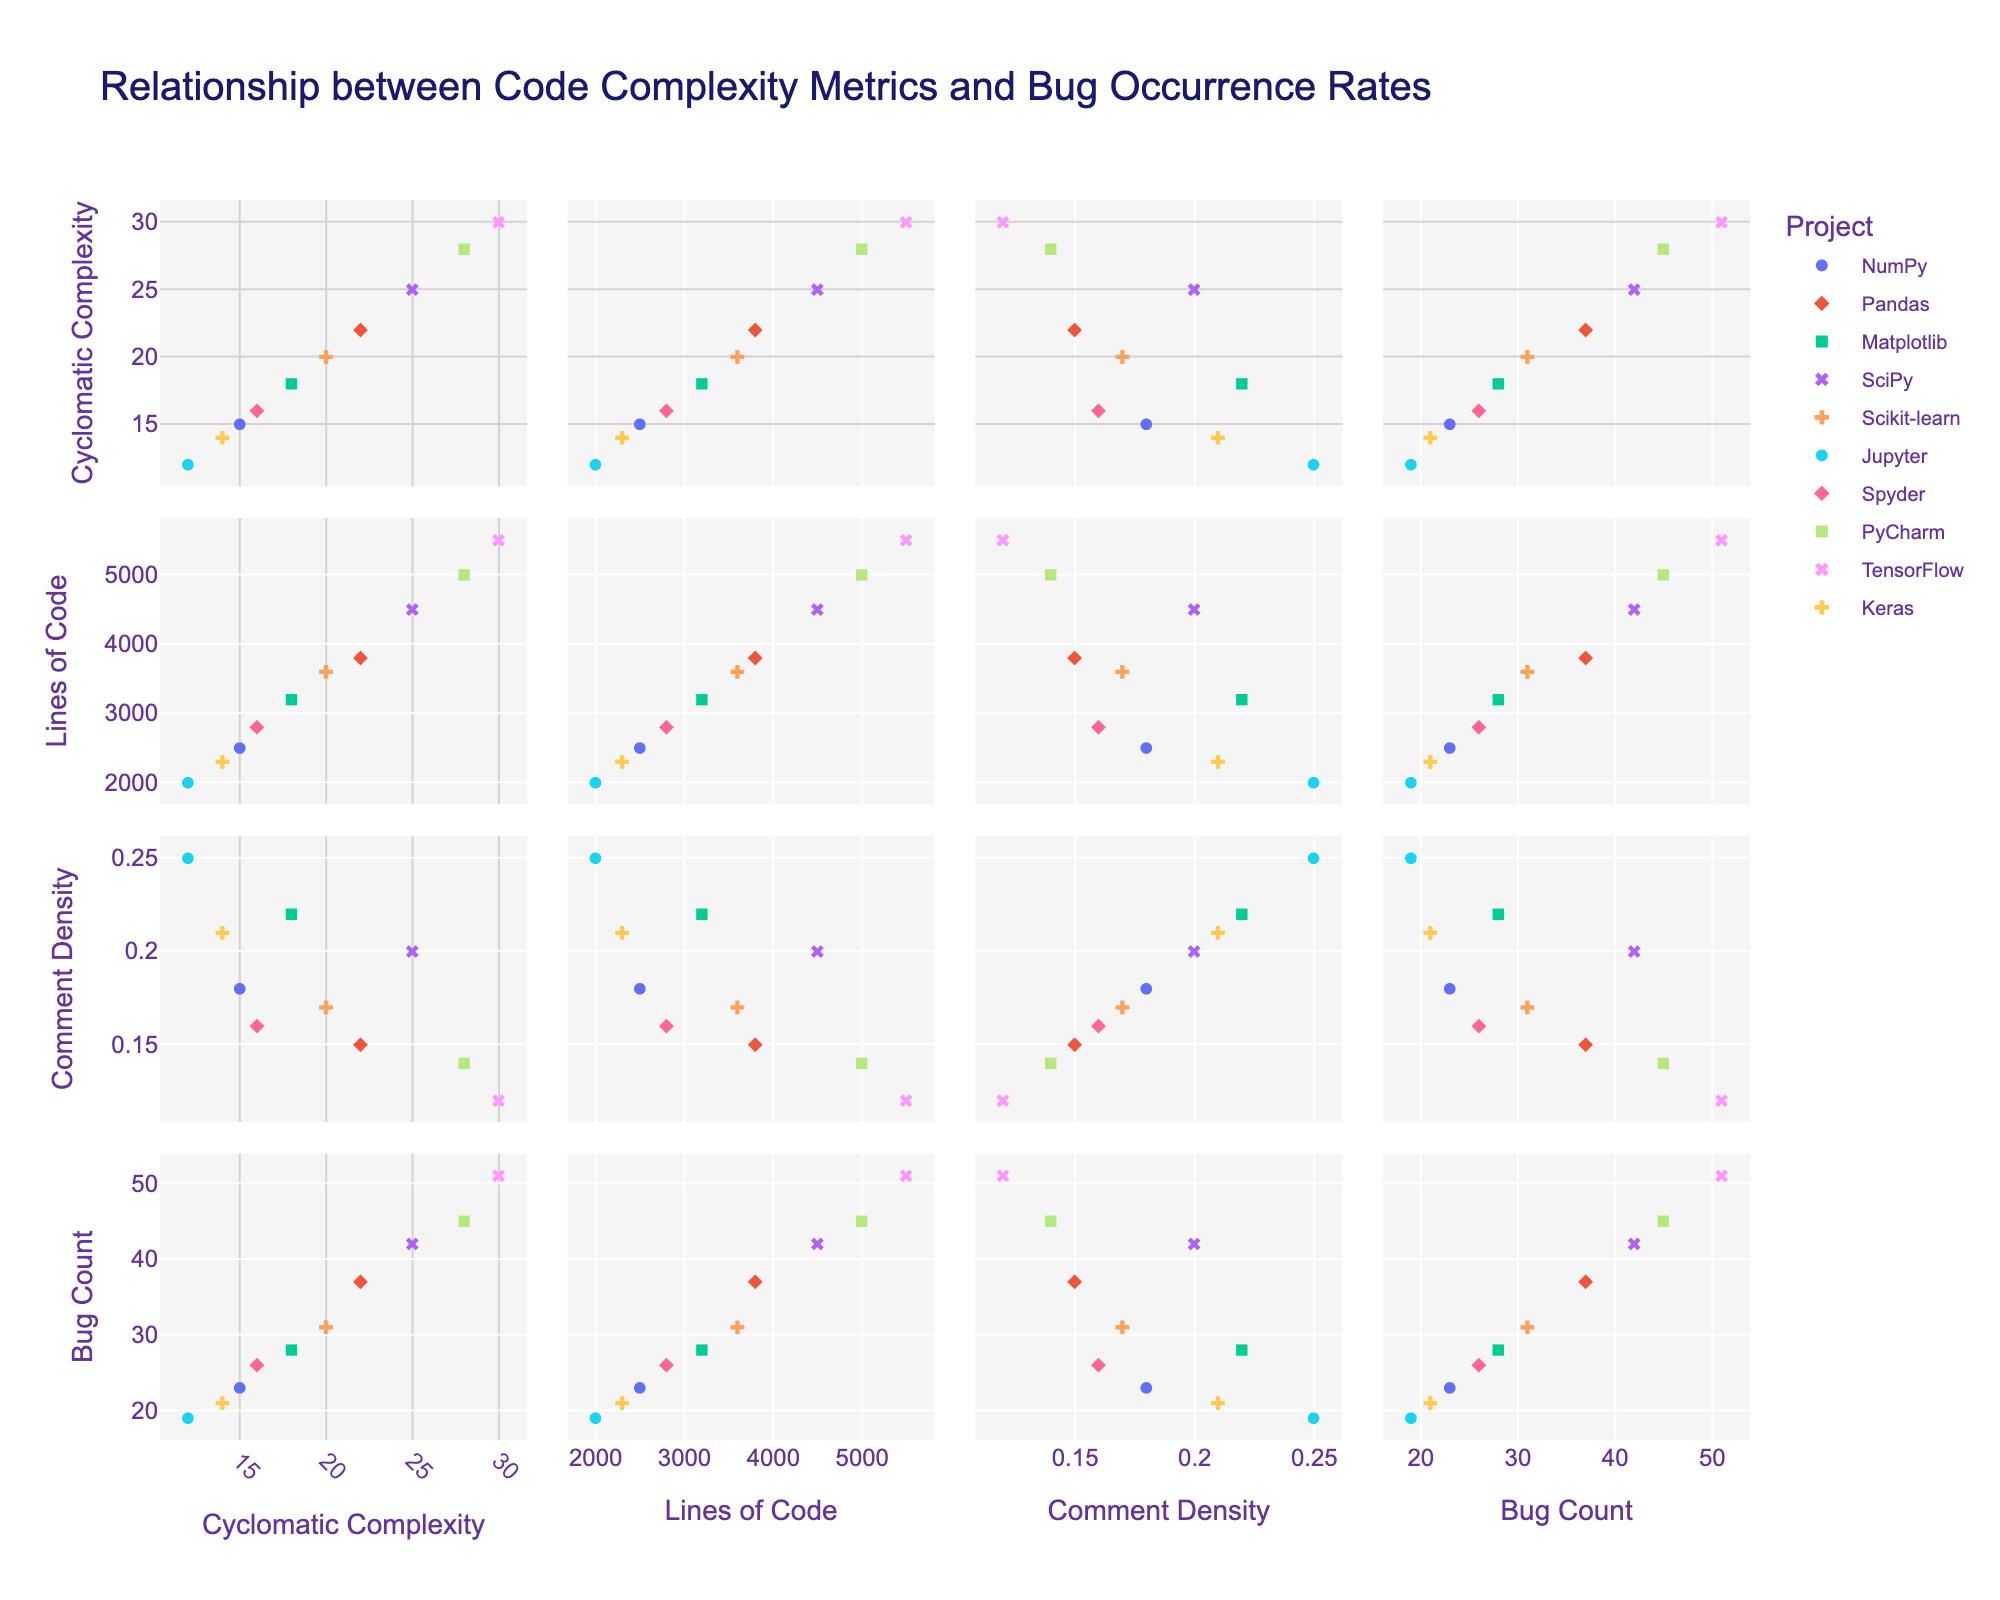what is the effect of code complexity on bug count in the projects? By looking at the scatterplot matrix, one can observe the trend between 'Cyclomatic Complexity' and 'Bug Count'. The matrix shows that as cyclomatic complexity increases in the diagonal subplots, generally, it appears that the bug count also increases, indicating a positive correlation.
Answer: Positive correlation How is 'Lines of Code' related to 'Bug Count'? In the scatterplot matrix, the relationship between 'Lines of Code' and 'Bug Count' can be observed in the specific scatter plot. There is a visible upward trend, suggesting that projects with more lines of code tend to have higher bug counts, which indicates a positive correlation.
Answer: Positive correlation What project has the highest bug count? By looking at the matrix, the project with the highest value on the 'bug_count' axis is identified. This is 'TensorFlow' with a bug count of 51.
Answer: TensorFlow Which project has the highest cyclomatic complexity? In the scatterplot matrix, 'PyCharm' has the highest value on the 'cyclomatic_complexity' axis with a complexity of 28.
Answer: PyCharm Is there any project with both low cyclomatic complexity and low bug count? One can find 'Jupyter' by examining the scatterplot matrix, which has both low cyclomatic complexity (12) and a low bug count (19).
Answer: Jupyter Compare the comment density between 'SciPy' and 'TensorFlow'. In the corresponding scatterplot, 'SciPy' has a comment density of 0.20, whereas 'TensorFlow' has a comment density of 0.12.
Answer: SciPy has higher comment density, 0.20 versus TensorFlow's 0.12 Which project has the highest comment density and how does its bug count compare to others? 'Jupyter' is observed to have the highest comment density at 0.25. Its bug count of 19 is one of the lowest compared to other projects.
Answer: Jupyter, low bug count of 19 Which two projects have the closest bug counts? Referring to the matrix, 'Matplotlib' and 'Scikit-learn' have very close bug counts of 28 and 31, respectively.
Answer: Matplotlib and Scikit-learn How does cyclomatic complexity compare for NumPy and Keras? Visually inspecting the scatterplot, 'NumPy' has a cyclomatic complexity of 15, and 'Keras' has a cyclomatic complexity of 14. The values are very close.
Answer: Very close, 15 and 14 respectively 